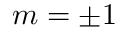Convert formula to latex. <formula><loc_0><loc_0><loc_500><loc_500>m = \pm 1</formula> 